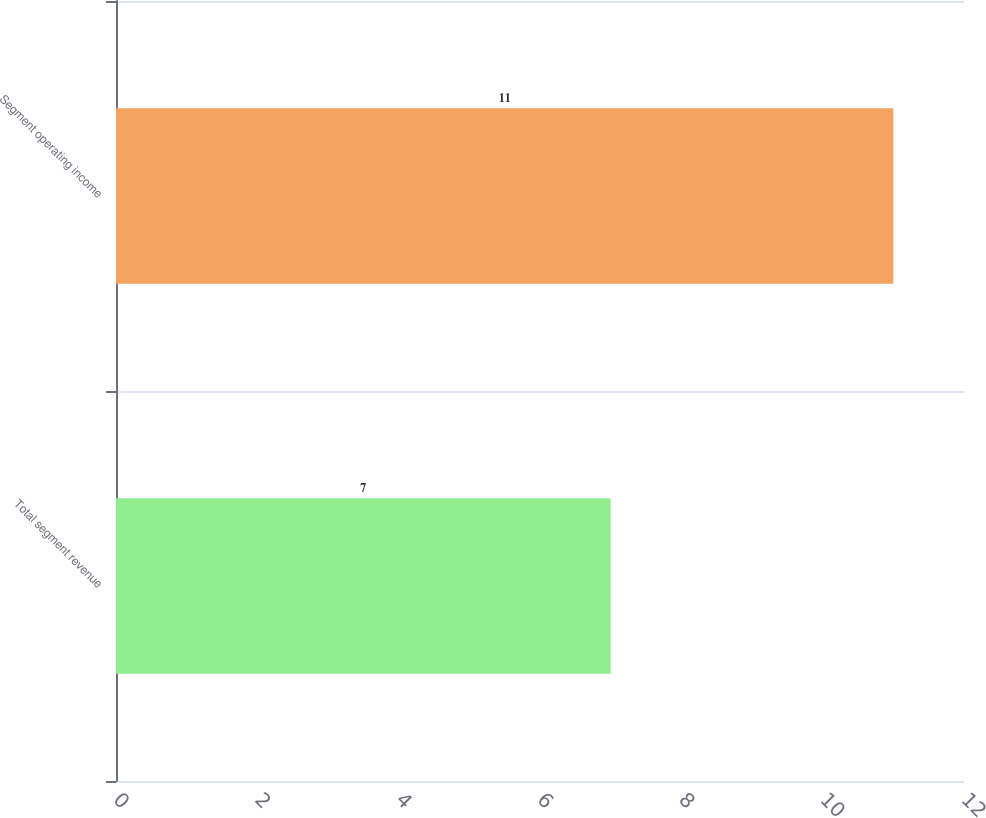Convert chart to OTSL. <chart><loc_0><loc_0><loc_500><loc_500><bar_chart><fcel>Total segment revenue<fcel>Segment operating income<nl><fcel>7<fcel>11<nl></chart> 